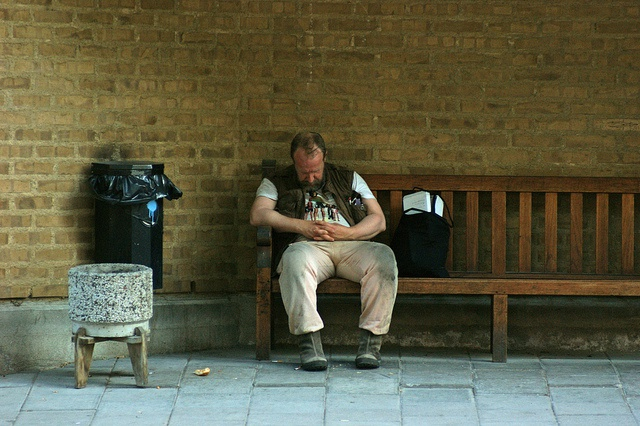Describe the objects in this image and their specific colors. I can see bench in olive, black, maroon, and brown tones, people in olive, black, gray, and darkgray tones, handbag in olive, black, gray, maroon, and darkgray tones, and backpack in olive, black, darkgray, and teal tones in this image. 